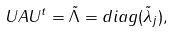<formula> <loc_0><loc_0><loc_500><loc_500>U A U ^ { t } = \tilde { \Lambda } = d i a g ( \tilde { \lambda } _ { j } ) ,</formula> 